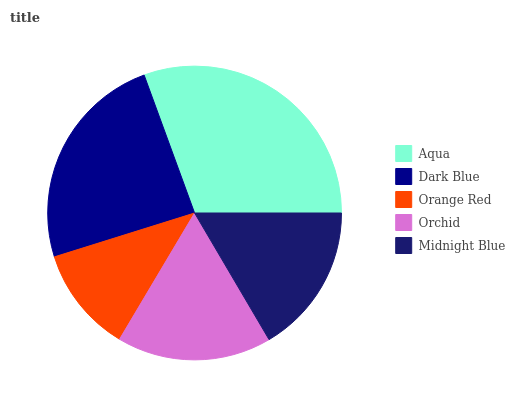Is Orange Red the minimum?
Answer yes or no. Yes. Is Aqua the maximum?
Answer yes or no. Yes. Is Dark Blue the minimum?
Answer yes or no. No. Is Dark Blue the maximum?
Answer yes or no. No. Is Aqua greater than Dark Blue?
Answer yes or no. Yes. Is Dark Blue less than Aqua?
Answer yes or no. Yes. Is Dark Blue greater than Aqua?
Answer yes or no. No. Is Aqua less than Dark Blue?
Answer yes or no. No. Is Orchid the high median?
Answer yes or no. Yes. Is Orchid the low median?
Answer yes or no. Yes. Is Orange Red the high median?
Answer yes or no. No. Is Orange Red the low median?
Answer yes or no. No. 